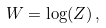Convert formula to latex. <formula><loc_0><loc_0><loc_500><loc_500>W = \log ( Z ) \, ,</formula> 